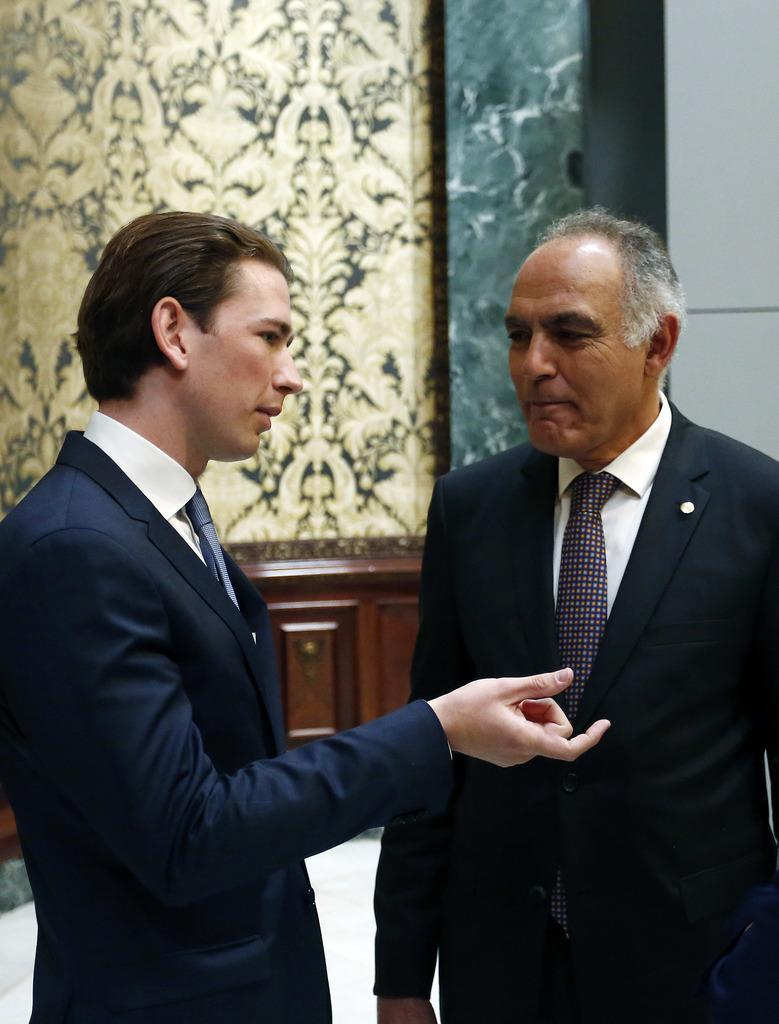How would you summarize this image in a sentence or two? In this image there are two men who are wearing the suits are talking with each other. In the background there is a wall on which there is a design. Below the wall there is a cupboard. 